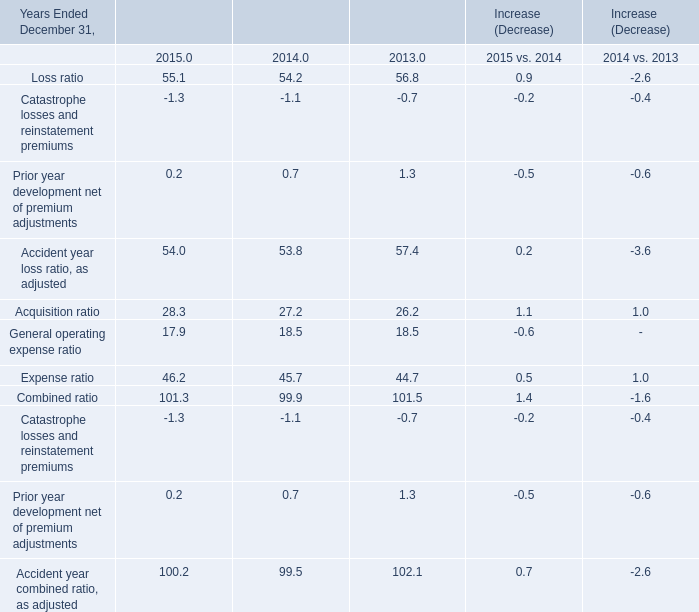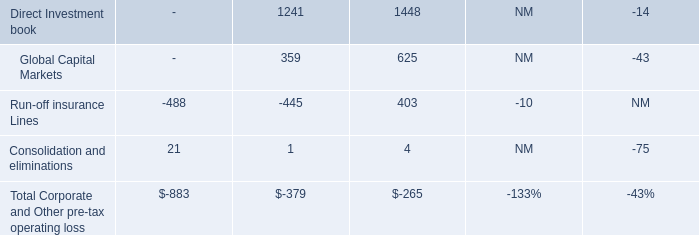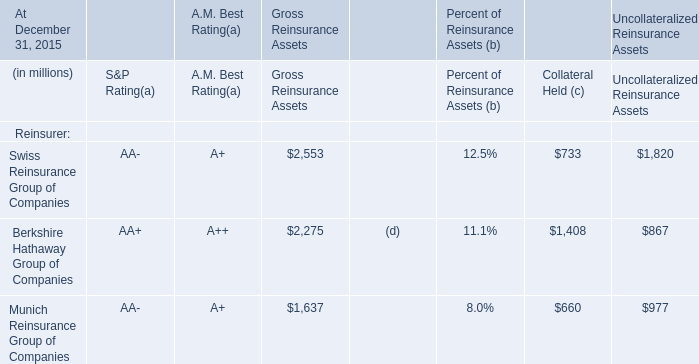If Loss ratio develops with the same growth rate in 2015, what will it reach in 2016? (in %) 
Computations: (55.1 + ((55.1 * (55.1 - 54.2)) / 54.2))
Answer: 56.01494. 